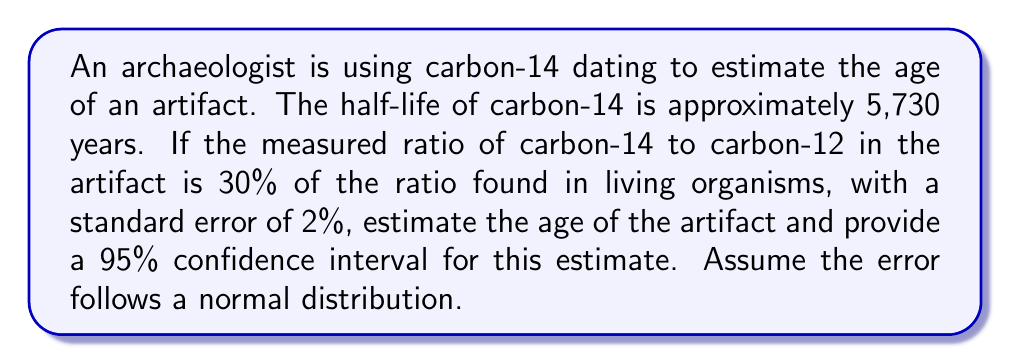Solve this math problem. To solve this problem, we'll follow these steps:

1) First, we need to calculate the age of the artifact based on the measured ratio:

   Let $t$ be the age of the artifact in years.
   Let $R$ be the ratio of carbon-14 to carbon-12.

   $R = R_0 \cdot (1/2)^{t/5730}$, where $R_0$ is the initial ratio.

   $0.30 = (1/2)^{t/5730}$

   Taking the natural log of both sides:

   $\ln(0.30) = \ln((1/2)^{t/5730}) = (t/5730) \cdot \ln(1/2)$

   $t = 5730 \cdot \frac{\ln(0.30)}{\ln(1/2)} \approx 9912.8$ years

2) Now, we need to calculate the standard error of this estimate:

   The relative error in the ratio measurement is 2% or 0.02.
   
   The standard error in $t$ can be approximated using the derivative of $t$ with respect to $R$:

   $\frac{dt}{dR} = -5730 \cdot \frac{1}{R \cdot \ln(1/2)}$

   At $R = 0.30$:

   $\frac{dt}{dR} \approx -45,388.5$

   The standard error in $t$ is thus:

   $SE_t = |-45,388.5| \cdot 0.02 \cdot 0.30 \approx 272.3$ years

3) For a 95% confidence interval, we use 1.96 standard errors on either side of the estimate:

   Lower bound: $9912.8 - 1.96 \cdot 272.3 \approx 9379.1$ years
   Upper bound: $9912.8 + 1.96 \cdot 272.3 \approx 10446.5$ years

Therefore, we estimate the age of the artifact to be about 9,913 years, with a 95% confidence interval of approximately (9,379, 10,447) years.
Answer: The estimated age of the artifact is 9,913 years, with a 95% confidence interval of (9,379, 10,447) years. 